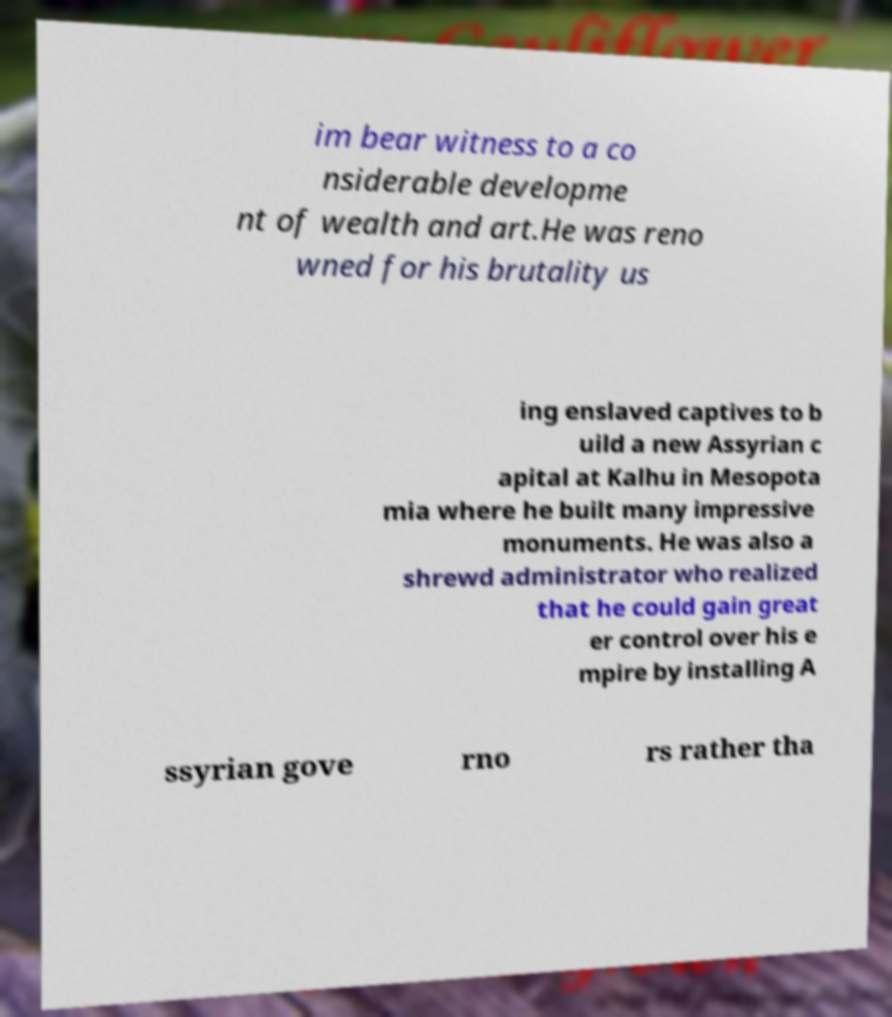Can you read and provide the text displayed in the image?This photo seems to have some interesting text. Can you extract and type it out for me? im bear witness to a co nsiderable developme nt of wealth and art.He was reno wned for his brutality us ing enslaved captives to b uild a new Assyrian c apital at Kalhu in Mesopota mia where he built many impressive monuments. He was also a shrewd administrator who realized that he could gain great er control over his e mpire by installing A ssyrian gove rno rs rather tha 